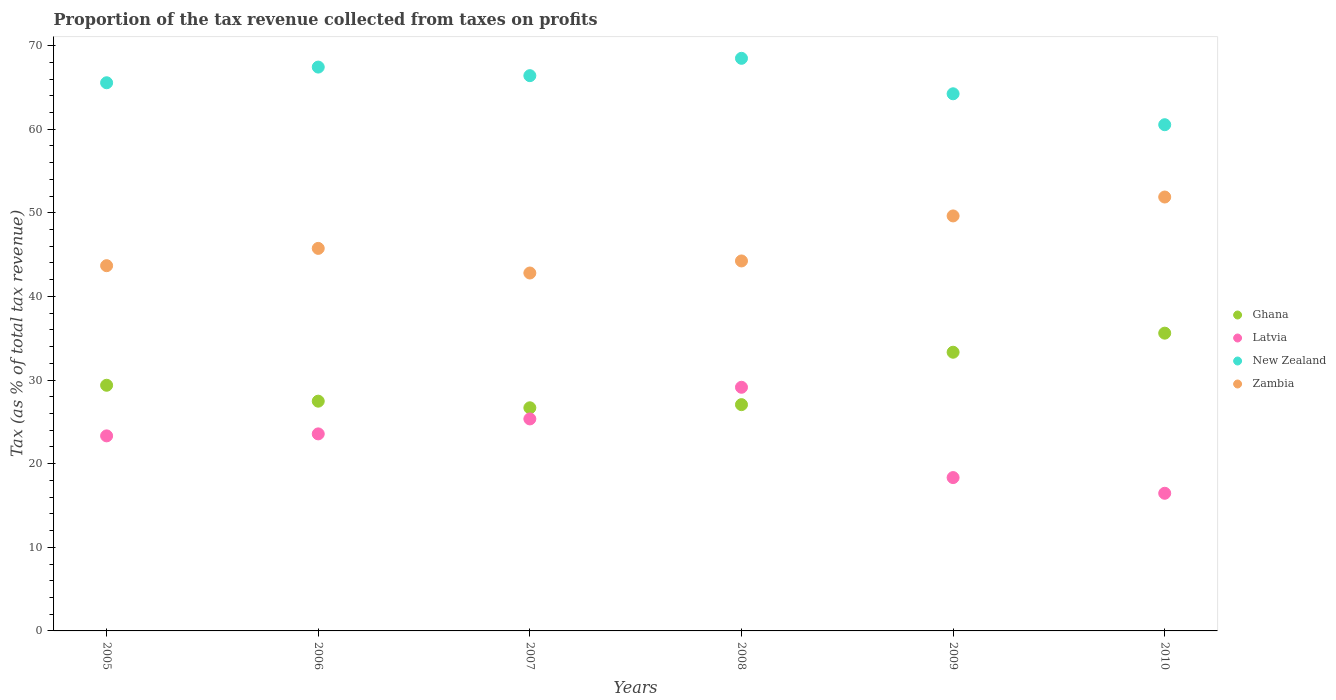What is the proportion of the tax revenue collected in New Zealand in 2007?
Your response must be concise. 66.4. Across all years, what is the maximum proportion of the tax revenue collected in New Zealand?
Your answer should be compact. 68.47. Across all years, what is the minimum proportion of the tax revenue collected in Latvia?
Keep it short and to the point. 16.46. What is the total proportion of the tax revenue collected in Latvia in the graph?
Provide a succinct answer. 136.17. What is the difference between the proportion of the tax revenue collected in Ghana in 2006 and that in 2010?
Make the answer very short. -8.13. What is the difference between the proportion of the tax revenue collected in New Zealand in 2008 and the proportion of the tax revenue collected in Zambia in 2010?
Provide a succinct answer. 16.59. What is the average proportion of the tax revenue collected in New Zealand per year?
Your answer should be compact. 65.44. In the year 2007, what is the difference between the proportion of the tax revenue collected in Ghana and proportion of the tax revenue collected in New Zealand?
Your answer should be very brief. -39.72. In how many years, is the proportion of the tax revenue collected in Zambia greater than 24 %?
Your response must be concise. 6. What is the ratio of the proportion of the tax revenue collected in Latvia in 2005 to that in 2010?
Ensure brevity in your answer.  1.42. Is the proportion of the tax revenue collected in Ghana in 2009 less than that in 2010?
Offer a terse response. Yes. What is the difference between the highest and the second highest proportion of the tax revenue collected in Latvia?
Your answer should be very brief. 3.78. What is the difference between the highest and the lowest proportion of the tax revenue collected in Zambia?
Ensure brevity in your answer.  9.09. In how many years, is the proportion of the tax revenue collected in Zambia greater than the average proportion of the tax revenue collected in Zambia taken over all years?
Give a very brief answer. 2. Is it the case that in every year, the sum of the proportion of the tax revenue collected in Zambia and proportion of the tax revenue collected in New Zealand  is greater than the sum of proportion of the tax revenue collected in Latvia and proportion of the tax revenue collected in Ghana?
Provide a succinct answer. No. Does the proportion of the tax revenue collected in Ghana monotonically increase over the years?
Keep it short and to the point. No. Is the proportion of the tax revenue collected in Zambia strictly greater than the proportion of the tax revenue collected in New Zealand over the years?
Ensure brevity in your answer.  No. Is the proportion of the tax revenue collected in Ghana strictly less than the proportion of the tax revenue collected in New Zealand over the years?
Your answer should be very brief. Yes. How many years are there in the graph?
Keep it short and to the point. 6. Does the graph contain any zero values?
Ensure brevity in your answer.  No. Does the graph contain grids?
Give a very brief answer. No. How many legend labels are there?
Make the answer very short. 4. How are the legend labels stacked?
Your response must be concise. Vertical. What is the title of the graph?
Ensure brevity in your answer.  Proportion of the tax revenue collected from taxes on profits. What is the label or title of the X-axis?
Offer a terse response. Years. What is the label or title of the Y-axis?
Provide a short and direct response. Tax (as % of total tax revenue). What is the Tax (as % of total tax revenue) in Ghana in 2005?
Your response must be concise. 29.38. What is the Tax (as % of total tax revenue) of Latvia in 2005?
Your answer should be compact. 23.32. What is the Tax (as % of total tax revenue) of New Zealand in 2005?
Offer a very short reply. 65.55. What is the Tax (as % of total tax revenue) of Zambia in 2005?
Your answer should be very brief. 43.68. What is the Tax (as % of total tax revenue) of Ghana in 2006?
Your answer should be compact. 27.47. What is the Tax (as % of total tax revenue) of Latvia in 2006?
Offer a terse response. 23.56. What is the Tax (as % of total tax revenue) of New Zealand in 2006?
Keep it short and to the point. 67.43. What is the Tax (as % of total tax revenue) of Zambia in 2006?
Provide a succinct answer. 45.74. What is the Tax (as % of total tax revenue) of Ghana in 2007?
Provide a short and direct response. 26.68. What is the Tax (as % of total tax revenue) of Latvia in 2007?
Give a very brief answer. 25.35. What is the Tax (as % of total tax revenue) in New Zealand in 2007?
Your answer should be very brief. 66.4. What is the Tax (as % of total tax revenue) in Zambia in 2007?
Your answer should be compact. 42.8. What is the Tax (as % of total tax revenue) in Ghana in 2008?
Ensure brevity in your answer.  27.06. What is the Tax (as % of total tax revenue) of Latvia in 2008?
Keep it short and to the point. 29.14. What is the Tax (as % of total tax revenue) of New Zealand in 2008?
Offer a very short reply. 68.47. What is the Tax (as % of total tax revenue) in Zambia in 2008?
Your answer should be compact. 44.24. What is the Tax (as % of total tax revenue) in Ghana in 2009?
Give a very brief answer. 33.33. What is the Tax (as % of total tax revenue) of Latvia in 2009?
Your answer should be compact. 18.34. What is the Tax (as % of total tax revenue) of New Zealand in 2009?
Keep it short and to the point. 64.23. What is the Tax (as % of total tax revenue) of Zambia in 2009?
Provide a short and direct response. 49.63. What is the Tax (as % of total tax revenue) in Ghana in 2010?
Give a very brief answer. 35.61. What is the Tax (as % of total tax revenue) in Latvia in 2010?
Offer a terse response. 16.46. What is the Tax (as % of total tax revenue) of New Zealand in 2010?
Provide a short and direct response. 60.53. What is the Tax (as % of total tax revenue) in Zambia in 2010?
Your answer should be compact. 51.89. Across all years, what is the maximum Tax (as % of total tax revenue) of Ghana?
Make the answer very short. 35.61. Across all years, what is the maximum Tax (as % of total tax revenue) of Latvia?
Your answer should be very brief. 29.14. Across all years, what is the maximum Tax (as % of total tax revenue) of New Zealand?
Provide a short and direct response. 68.47. Across all years, what is the maximum Tax (as % of total tax revenue) of Zambia?
Ensure brevity in your answer.  51.89. Across all years, what is the minimum Tax (as % of total tax revenue) in Ghana?
Your answer should be compact. 26.68. Across all years, what is the minimum Tax (as % of total tax revenue) of Latvia?
Offer a very short reply. 16.46. Across all years, what is the minimum Tax (as % of total tax revenue) in New Zealand?
Offer a terse response. 60.53. Across all years, what is the minimum Tax (as % of total tax revenue) of Zambia?
Your response must be concise. 42.8. What is the total Tax (as % of total tax revenue) in Ghana in the graph?
Your response must be concise. 179.53. What is the total Tax (as % of total tax revenue) in Latvia in the graph?
Offer a very short reply. 136.17. What is the total Tax (as % of total tax revenue) in New Zealand in the graph?
Your answer should be very brief. 392.62. What is the total Tax (as % of total tax revenue) in Zambia in the graph?
Your answer should be compact. 277.98. What is the difference between the Tax (as % of total tax revenue) of Ghana in 2005 and that in 2006?
Ensure brevity in your answer.  1.9. What is the difference between the Tax (as % of total tax revenue) of Latvia in 2005 and that in 2006?
Your response must be concise. -0.24. What is the difference between the Tax (as % of total tax revenue) in New Zealand in 2005 and that in 2006?
Keep it short and to the point. -1.88. What is the difference between the Tax (as % of total tax revenue) of Zambia in 2005 and that in 2006?
Give a very brief answer. -2.07. What is the difference between the Tax (as % of total tax revenue) in Ghana in 2005 and that in 2007?
Your answer should be compact. 2.69. What is the difference between the Tax (as % of total tax revenue) in Latvia in 2005 and that in 2007?
Your answer should be compact. -2.03. What is the difference between the Tax (as % of total tax revenue) in New Zealand in 2005 and that in 2007?
Ensure brevity in your answer.  -0.85. What is the difference between the Tax (as % of total tax revenue) of Zambia in 2005 and that in 2007?
Offer a very short reply. 0.88. What is the difference between the Tax (as % of total tax revenue) of Ghana in 2005 and that in 2008?
Ensure brevity in your answer.  2.32. What is the difference between the Tax (as % of total tax revenue) of Latvia in 2005 and that in 2008?
Keep it short and to the point. -5.81. What is the difference between the Tax (as % of total tax revenue) of New Zealand in 2005 and that in 2008?
Keep it short and to the point. -2.92. What is the difference between the Tax (as % of total tax revenue) of Zambia in 2005 and that in 2008?
Provide a short and direct response. -0.57. What is the difference between the Tax (as % of total tax revenue) in Ghana in 2005 and that in 2009?
Your response must be concise. -3.95. What is the difference between the Tax (as % of total tax revenue) in Latvia in 2005 and that in 2009?
Provide a succinct answer. 4.99. What is the difference between the Tax (as % of total tax revenue) in New Zealand in 2005 and that in 2009?
Give a very brief answer. 1.32. What is the difference between the Tax (as % of total tax revenue) in Zambia in 2005 and that in 2009?
Ensure brevity in your answer.  -5.95. What is the difference between the Tax (as % of total tax revenue) in Ghana in 2005 and that in 2010?
Make the answer very short. -6.23. What is the difference between the Tax (as % of total tax revenue) of Latvia in 2005 and that in 2010?
Provide a succinct answer. 6.86. What is the difference between the Tax (as % of total tax revenue) of New Zealand in 2005 and that in 2010?
Your answer should be very brief. 5.02. What is the difference between the Tax (as % of total tax revenue) in Zambia in 2005 and that in 2010?
Provide a short and direct response. -8.21. What is the difference between the Tax (as % of total tax revenue) in Ghana in 2006 and that in 2007?
Offer a terse response. 0.79. What is the difference between the Tax (as % of total tax revenue) in Latvia in 2006 and that in 2007?
Your answer should be very brief. -1.79. What is the difference between the Tax (as % of total tax revenue) in New Zealand in 2006 and that in 2007?
Offer a very short reply. 1.03. What is the difference between the Tax (as % of total tax revenue) in Zambia in 2006 and that in 2007?
Your answer should be very brief. 2.94. What is the difference between the Tax (as % of total tax revenue) of Ghana in 2006 and that in 2008?
Offer a very short reply. 0.42. What is the difference between the Tax (as % of total tax revenue) of Latvia in 2006 and that in 2008?
Offer a terse response. -5.57. What is the difference between the Tax (as % of total tax revenue) in New Zealand in 2006 and that in 2008?
Keep it short and to the point. -1.05. What is the difference between the Tax (as % of total tax revenue) of Zambia in 2006 and that in 2008?
Your response must be concise. 1.5. What is the difference between the Tax (as % of total tax revenue) of Ghana in 2006 and that in 2009?
Keep it short and to the point. -5.85. What is the difference between the Tax (as % of total tax revenue) of Latvia in 2006 and that in 2009?
Offer a very short reply. 5.22. What is the difference between the Tax (as % of total tax revenue) of New Zealand in 2006 and that in 2009?
Offer a very short reply. 3.19. What is the difference between the Tax (as % of total tax revenue) of Zambia in 2006 and that in 2009?
Your response must be concise. -3.88. What is the difference between the Tax (as % of total tax revenue) of Ghana in 2006 and that in 2010?
Provide a short and direct response. -8.13. What is the difference between the Tax (as % of total tax revenue) in Latvia in 2006 and that in 2010?
Ensure brevity in your answer.  7.1. What is the difference between the Tax (as % of total tax revenue) in New Zealand in 2006 and that in 2010?
Provide a succinct answer. 6.89. What is the difference between the Tax (as % of total tax revenue) in Zambia in 2006 and that in 2010?
Your answer should be very brief. -6.14. What is the difference between the Tax (as % of total tax revenue) in Ghana in 2007 and that in 2008?
Your answer should be very brief. -0.38. What is the difference between the Tax (as % of total tax revenue) of Latvia in 2007 and that in 2008?
Your answer should be compact. -3.78. What is the difference between the Tax (as % of total tax revenue) of New Zealand in 2007 and that in 2008?
Offer a terse response. -2.07. What is the difference between the Tax (as % of total tax revenue) of Zambia in 2007 and that in 2008?
Provide a short and direct response. -1.44. What is the difference between the Tax (as % of total tax revenue) in Ghana in 2007 and that in 2009?
Provide a succinct answer. -6.64. What is the difference between the Tax (as % of total tax revenue) of Latvia in 2007 and that in 2009?
Offer a terse response. 7.01. What is the difference between the Tax (as % of total tax revenue) in New Zealand in 2007 and that in 2009?
Offer a very short reply. 2.17. What is the difference between the Tax (as % of total tax revenue) in Zambia in 2007 and that in 2009?
Give a very brief answer. -6.83. What is the difference between the Tax (as % of total tax revenue) in Ghana in 2007 and that in 2010?
Provide a succinct answer. -8.92. What is the difference between the Tax (as % of total tax revenue) of Latvia in 2007 and that in 2010?
Your response must be concise. 8.89. What is the difference between the Tax (as % of total tax revenue) in New Zealand in 2007 and that in 2010?
Your answer should be very brief. 5.87. What is the difference between the Tax (as % of total tax revenue) in Zambia in 2007 and that in 2010?
Your response must be concise. -9.09. What is the difference between the Tax (as % of total tax revenue) in Ghana in 2008 and that in 2009?
Provide a succinct answer. -6.27. What is the difference between the Tax (as % of total tax revenue) of Latvia in 2008 and that in 2009?
Your answer should be very brief. 10.8. What is the difference between the Tax (as % of total tax revenue) in New Zealand in 2008 and that in 2009?
Ensure brevity in your answer.  4.24. What is the difference between the Tax (as % of total tax revenue) of Zambia in 2008 and that in 2009?
Provide a short and direct response. -5.38. What is the difference between the Tax (as % of total tax revenue) in Ghana in 2008 and that in 2010?
Provide a succinct answer. -8.55. What is the difference between the Tax (as % of total tax revenue) in Latvia in 2008 and that in 2010?
Ensure brevity in your answer.  12.68. What is the difference between the Tax (as % of total tax revenue) of New Zealand in 2008 and that in 2010?
Keep it short and to the point. 7.94. What is the difference between the Tax (as % of total tax revenue) of Zambia in 2008 and that in 2010?
Give a very brief answer. -7.64. What is the difference between the Tax (as % of total tax revenue) of Ghana in 2009 and that in 2010?
Your answer should be compact. -2.28. What is the difference between the Tax (as % of total tax revenue) in Latvia in 2009 and that in 2010?
Provide a short and direct response. 1.88. What is the difference between the Tax (as % of total tax revenue) in New Zealand in 2009 and that in 2010?
Offer a very short reply. 3.7. What is the difference between the Tax (as % of total tax revenue) in Zambia in 2009 and that in 2010?
Make the answer very short. -2.26. What is the difference between the Tax (as % of total tax revenue) of Ghana in 2005 and the Tax (as % of total tax revenue) of Latvia in 2006?
Give a very brief answer. 5.81. What is the difference between the Tax (as % of total tax revenue) of Ghana in 2005 and the Tax (as % of total tax revenue) of New Zealand in 2006?
Provide a succinct answer. -38.05. What is the difference between the Tax (as % of total tax revenue) of Ghana in 2005 and the Tax (as % of total tax revenue) of Zambia in 2006?
Your answer should be very brief. -16.37. What is the difference between the Tax (as % of total tax revenue) in Latvia in 2005 and the Tax (as % of total tax revenue) in New Zealand in 2006?
Your answer should be very brief. -44.1. What is the difference between the Tax (as % of total tax revenue) of Latvia in 2005 and the Tax (as % of total tax revenue) of Zambia in 2006?
Provide a succinct answer. -22.42. What is the difference between the Tax (as % of total tax revenue) of New Zealand in 2005 and the Tax (as % of total tax revenue) of Zambia in 2006?
Your answer should be very brief. 19.81. What is the difference between the Tax (as % of total tax revenue) in Ghana in 2005 and the Tax (as % of total tax revenue) in Latvia in 2007?
Provide a short and direct response. 4.02. What is the difference between the Tax (as % of total tax revenue) in Ghana in 2005 and the Tax (as % of total tax revenue) in New Zealand in 2007?
Provide a short and direct response. -37.02. What is the difference between the Tax (as % of total tax revenue) in Ghana in 2005 and the Tax (as % of total tax revenue) in Zambia in 2007?
Give a very brief answer. -13.42. What is the difference between the Tax (as % of total tax revenue) of Latvia in 2005 and the Tax (as % of total tax revenue) of New Zealand in 2007?
Your answer should be compact. -43.07. What is the difference between the Tax (as % of total tax revenue) of Latvia in 2005 and the Tax (as % of total tax revenue) of Zambia in 2007?
Keep it short and to the point. -19.48. What is the difference between the Tax (as % of total tax revenue) of New Zealand in 2005 and the Tax (as % of total tax revenue) of Zambia in 2007?
Offer a terse response. 22.75. What is the difference between the Tax (as % of total tax revenue) in Ghana in 2005 and the Tax (as % of total tax revenue) in Latvia in 2008?
Provide a succinct answer. 0.24. What is the difference between the Tax (as % of total tax revenue) in Ghana in 2005 and the Tax (as % of total tax revenue) in New Zealand in 2008?
Make the answer very short. -39.1. What is the difference between the Tax (as % of total tax revenue) in Ghana in 2005 and the Tax (as % of total tax revenue) in Zambia in 2008?
Ensure brevity in your answer.  -14.87. What is the difference between the Tax (as % of total tax revenue) of Latvia in 2005 and the Tax (as % of total tax revenue) of New Zealand in 2008?
Your response must be concise. -45.15. What is the difference between the Tax (as % of total tax revenue) of Latvia in 2005 and the Tax (as % of total tax revenue) of Zambia in 2008?
Offer a very short reply. -20.92. What is the difference between the Tax (as % of total tax revenue) in New Zealand in 2005 and the Tax (as % of total tax revenue) in Zambia in 2008?
Give a very brief answer. 21.31. What is the difference between the Tax (as % of total tax revenue) of Ghana in 2005 and the Tax (as % of total tax revenue) of Latvia in 2009?
Your response must be concise. 11.04. What is the difference between the Tax (as % of total tax revenue) of Ghana in 2005 and the Tax (as % of total tax revenue) of New Zealand in 2009?
Offer a terse response. -34.86. What is the difference between the Tax (as % of total tax revenue) of Ghana in 2005 and the Tax (as % of total tax revenue) of Zambia in 2009?
Offer a terse response. -20.25. What is the difference between the Tax (as % of total tax revenue) of Latvia in 2005 and the Tax (as % of total tax revenue) of New Zealand in 2009?
Make the answer very short. -40.91. What is the difference between the Tax (as % of total tax revenue) of Latvia in 2005 and the Tax (as % of total tax revenue) of Zambia in 2009?
Keep it short and to the point. -26.3. What is the difference between the Tax (as % of total tax revenue) of New Zealand in 2005 and the Tax (as % of total tax revenue) of Zambia in 2009?
Your answer should be compact. 15.92. What is the difference between the Tax (as % of total tax revenue) in Ghana in 2005 and the Tax (as % of total tax revenue) in Latvia in 2010?
Provide a short and direct response. 12.92. What is the difference between the Tax (as % of total tax revenue) of Ghana in 2005 and the Tax (as % of total tax revenue) of New Zealand in 2010?
Keep it short and to the point. -31.16. What is the difference between the Tax (as % of total tax revenue) of Ghana in 2005 and the Tax (as % of total tax revenue) of Zambia in 2010?
Your answer should be very brief. -22.51. What is the difference between the Tax (as % of total tax revenue) in Latvia in 2005 and the Tax (as % of total tax revenue) in New Zealand in 2010?
Give a very brief answer. -37.21. What is the difference between the Tax (as % of total tax revenue) of Latvia in 2005 and the Tax (as % of total tax revenue) of Zambia in 2010?
Your response must be concise. -28.56. What is the difference between the Tax (as % of total tax revenue) of New Zealand in 2005 and the Tax (as % of total tax revenue) of Zambia in 2010?
Provide a succinct answer. 13.66. What is the difference between the Tax (as % of total tax revenue) in Ghana in 2006 and the Tax (as % of total tax revenue) in Latvia in 2007?
Make the answer very short. 2.12. What is the difference between the Tax (as % of total tax revenue) in Ghana in 2006 and the Tax (as % of total tax revenue) in New Zealand in 2007?
Give a very brief answer. -38.92. What is the difference between the Tax (as % of total tax revenue) in Ghana in 2006 and the Tax (as % of total tax revenue) in Zambia in 2007?
Provide a short and direct response. -15.33. What is the difference between the Tax (as % of total tax revenue) in Latvia in 2006 and the Tax (as % of total tax revenue) in New Zealand in 2007?
Your answer should be very brief. -42.84. What is the difference between the Tax (as % of total tax revenue) of Latvia in 2006 and the Tax (as % of total tax revenue) of Zambia in 2007?
Your answer should be very brief. -19.24. What is the difference between the Tax (as % of total tax revenue) of New Zealand in 2006 and the Tax (as % of total tax revenue) of Zambia in 2007?
Your response must be concise. 24.63. What is the difference between the Tax (as % of total tax revenue) of Ghana in 2006 and the Tax (as % of total tax revenue) of Latvia in 2008?
Your response must be concise. -1.66. What is the difference between the Tax (as % of total tax revenue) in Ghana in 2006 and the Tax (as % of total tax revenue) in New Zealand in 2008?
Provide a succinct answer. -41. What is the difference between the Tax (as % of total tax revenue) of Ghana in 2006 and the Tax (as % of total tax revenue) of Zambia in 2008?
Offer a very short reply. -16.77. What is the difference between the Tax (as % of total tax revenue) in Latvia in 2006 and the Tax (as % of total tax revenue) in New Zealand in 2008?
Provide a short and direct response. -44.91. What is the difference between the Tax (as % of total tax revenue) of Latvia in 2006 and the Tax (as % of total tax revenue) of Zambia in 2008?
Your response must be concise. -20.68. What is the difference between the Tax (as % of total tax revenue) of New Zealand in 2006 and the Tax (as % of total tax revenue) of Zambia in 2008?
Make the answer very short. 23.18. What is the difference between the Tax (as % of total tax revenue) of Ghana in 2006 and the Tax (as % of total tax revenue) of Latvia in 2009?
Offer a very short reply. 9.14. What is the difference between the Tax (as % of total tax revenue) in Ghana in 2006 and the Tax (as % of total tax revenue) in New Zealand in 2009?
Provide a short and direct response. -36.76. What is the difference between the Tax (as % of total tax revenue) of Ghana in 2006 and the Tax (as % of total tax revenue) of Zambia in 2009?
Make the answer very short. -22.15. What is the difference between the Tax (as % of total tax revenue) in Latvia in 2006 and the Tax (as % of total tax revenue) in New Zealand in 2009?
Provide a short and direct response. -40.67. What is the difference between the Tax (as % of total tax revenue) in Latvia in 2006 and the Tax (as % of total tax revenue) in Zambia in 2009?
Give a very brief answer. -26.07. What is the difference between the Tax (as % of total tax revenue) of New Zealand in 2006 and the Tax (as % of total tax revenue) of Zambia in 2009?
Keep it short and to the point. 17.8. What is the difference between the Tax (as % of total tax revenue) of Ghana in 2006 and the Tax (as % of total tax revenue) of Latvia in 2010?
Offer a very short reply. 11.01. What is the difference between the Tax (as % of total tax revenue) in Ghana in 2006 and the Tax (as % of total tax revenue) in New Zealand in 2010?
Ensure brevity in your answer.  -33.06. What is the difference between the Tax (as % of total tax revenue) in Ghana in 2006 and the Tax (as % of total tax revenue) in Zambia in 2010?
Keep it short and to the point. -24.41. What is the difference between the Tax (as % of total tax revenue) in Latvia in 2006 and the Tax (as % of total tax revenue) in New Zealand in 2010?
Offer a very short reply. -36.97. What is the difference between the Tax (as % of total tax revenue) of Latvia in 2006 and the Tax (as % of total tax revenue) of Zambia in 2010?
Your response must be concise. -28.33. What is the difference between the Tax (as % of total tax revenue) in New Zealand in 2006 and the Tax (as % of total tax revenue) in Zambia in 2010?
Ensure brevity in your answer.  15.54. What is the difference between the Tax (as % of total tax revenue) in Ghana in 2007 and the Tax (as % of total tax revenue) in Latvia in 2008?
Your answer should be very brief. -2.45. What is the difference between the Tax (as % of total tax revenue) in Ghana in 2007 and the Tax (as % of total tax revenue) in New Zealand in 2008?
Make the answer very short. -41.79. What is the difference between the Tax (as % of total tax revenue) in Ghana in 2007 and the Tax (as % of total tax revenue) in Zambia in 2008?
Your response must be concise. -17.56. What is the difference between the Tax (as % of total tax revenue) in Latvia in 2007 and the Tax (as % of total tax revenue) in New Zealand in 2008?
Your response must be concise. -43.12. What is the difference between the Tax (as % of total tax revenue) of Latvia in 2007 and the Tax (as % of total tax revenue) of Zambia in 2008?
Provide a short and direct response. -18.89. What is the difference between the Tax (as % of total tax revenue) of New Zealand in 2007 and the Tax (as % of total tax revenue) of Zambia in 2008?
Your response must be concise. 22.16. What is the difference between the Tax (as % of total tax revenue) in Ghana in 2007 and the Tax (as % of total tax revenue) in Latvia in 2009?
Offer a very short reply. 8.35. What is the difference between the Tax (as % of total tax revenue) in Ghana in 2007 and the Tax (as % of total tax revenue) in New Zealand in 2009?
Give a very brief answer. -37.55. What is the difference between the Tax (as % of total tax revenue) of Ghana in 2007 and the Tax (as % of total tax revenue) of Zambia in 2009?
Your answer should be very brief. -22.94. What is the difference between the Tax (as % of total tax revenue) of Latvia in 2007 and the Tax (as % of total tax revenue) of New Zealand in 2009?
Your answer should be compact. -38.88. What is the difference between the Tax (as % of total tax revenue) of Latvia in 2007 and the Tax (as % of total tax revenue) of Zambia in 2009?
Provide a short and direct response. -24.28. What is the difference between the Tax (as % of total tax revenue) in New Zealand in 2007 and the Tax (as % of total tax revenue) in Zambia in 2009?
Offer a very short reply. 16.77. What is the difference between the Tax (as % of total tax revenue) in Ghana in 2007 and the Tax (as % of total tax revenue) in Latvia in 2010?
Ensure brevity in your answer.  10.22. What is the difference between the Tax (as % of total tax revenue) in Ghana in 2007 and the Tax (as % of total tax revenue) in New Zealand in 2010?
Provide a short and direct response. -33.85. What is the difference between the Tax (as % of total tax revenue) of Ghana in 2007 and the Tax (as % of total tax revenue) of Zambia in 2010?
Provide a short and direct response. -25.2. What is the difference between the Tax (as % of total tax revenue) of Latvia in 2007 and the Tax (as % of total tax revenue) of New Zealand in 2010?
Make the answer very short. -35.18. What is the difference between the Tax (as % of total tax revenue) of Latvia in 2007 and the Tax (as % of total tax revenue) of Zambia in 2010?
Offer a very short reply. -26.54. What is the difference between the Tax (as % of total tax revenue) of New Zealand in 2007 and the Tax (as % of total tax revenue) of Zambia in 2010?
Make the answer very short. 14.51. What is the difference between the Tax (as % of total tax revenue) of Ghana in 2008 and the Tax (as % of total tax revenue) of Latvia in 2009?
Give a very brief answer. 8.72. What is the difference between the Tax (as % of total tax revenue) of Ghana in 2008 and the Tax (as % of total tax revenue) of New Zealand in 2009?
Ensure brevity in your answer.  -37.17. What is the difference between the Tax (as % of total tax revenue) of Ghana in 2008 and the Tax (as % of total tax revenue) of Zambia in 2009?
Offer a very short reply. -22.57. What is the difference between the Tax (as % of total tax revenue) in Latvia in 2008 and the Tax (as % of total tax revenue) in New Zealand in 2009?
Your answer should be very brief. -35.1. What is the difference between the Tax (as % of total tax revenue) in Latvia in 2008 and the Tax (as % of total tax revenue) in Zambia in 2009?
Give a very brief answer. -20.49. What is the difference between the Tax (as % of total tax revenue) in New Zealand in 2008 and the Tax (as % of total tax revenue) in Zambia in 2009?
Ensure brevity in your answer.  18.85. What is the difference between the Tax (as % of total tax revenue) of Ghana in 2008 and the Tax (as % of total tax revenue) of Latvia in 2010?
Offer a terse response. 10.6. What is the difference between the Tax (as % of total tax revenue) in Ghana in 2008 and the Tax (as % of total tax revenue) in New Zealand in 2010?
Provide a succinct answer. -33.47. What is the difference between the Tax (as % of total tax revenue) in Ghana in 2008 and the Tax (as % of total tax revenue) in Zambia in 2010?
Your answer should be very brief. -24.83. What is the difference between the Tax (as % of total tax revenue) in Latvia in 2008 and the Tax (as % of total tax revenue) in New Zealand in 2010?
Provide a succinct answer. -31.4. What is the difference between the Tax (as % of total tax revenue) of Latvia in 2008 and the Tax (as % of total tax revenue) of Zambia in 2010?
Your answer should be very brief. -22.75. What is the difference between the Tax (as % of total tax revenue) in New Zealand in 2008 and the Tax (as % of total tax revenue) in Zambia in 2010?
Provide a short and direct response. 16.59. What is the difference between the Tax (as % of total tax revenue) of Ghana in 2009 and the Tax (as % of total tax revenue) of Latvia in 2010?
Give a very brief answer. 16.87. What is the difference between the Tax (as % of total tax revenue) in Ghana in 2009 and the Tax (as % of total tax revenue) in New Zealand in 2010?
Offer a terse response. -27.21. What is the difference between the Tax (as % of total tax revenue) of Ghana in 2009 and the Tax (as % of total tax revenue) of Zambia in 2010?
Provide a succinct answer. -18.56. What is the difference between the Tax (as % of total tax revenue) in Latvia in 2009 and the Tax (as % of total tax revenue) in New Zealand in 2010?
Make the answer very short. -42.2. What is the difference between the Tax (as % of total tax revenue) of Latvia in 2009 and the Tax (as % of total tax revenue) of Zambia in 2010?
Offer a terse response. -33.55. What is the difference between the Tax (as % of total tax revenue) in New Zealand in 2009 and the Tax (as % of total tax revenue) in Zambia in 2010?
Your answer should be very brief. 12.34. What is the average Tax (as % of total tax revenue) in Ghana per year?
Offer a very short reply. 29.92. What is the average Tax (as % of total tax revenue) in Latvia per year?
Your response must be concise. 22.7. What is the average Tax (as % of total tax revenue) in New Zealand per year?
Provide a succinct answer. 65.44. What is the average Tax (as % of total tax revenue) in Zambia per year?
Make the answer very short. 46.33. In the year 2005, what is the difference between the Tax (as % of total tax revenue) of Ghana and Tax (as % of total tax revenue) of Latvia?
Provide a short and direct response. 6.05. In the year 2005, what is the difference between the Tax (as % of total tax revenue) in Ghana and Tax (as % of total tax revenue) in New Zealand?
Provide a short and direct response. -36.17. In the year 2005, what is the difference between the Tax (as % of total tax revenue) in Ghana and Tax (as % of total tax revenue) in Zambia?
Your answer should be compact. -14.3. In the year 2005, what is the difference between the Tax (as % of total tax revenue) in Latvia and Tax (as % of total tax revenue) in New Zealand?
Offer a very short reply. -42.23. In the year 2005, what is the difference between the Tax (as % of total tax revenue) in Latvia and Tax (as % of total tax revenue) in Zambia?
Give a very brief answer. -20.35. In the year 2005, what is the difference between the Tax (as % of total tax revenue) of New Zealand and Tax (as % of total tax revenue) of Zambia?
Your answer should be compact. 21.87. In the year 2006, what is the difference between the Tax (as % of total tax revenue) in Ghana and Tax (as % of total tax revenue) in Latvia?
Offer a very short reply. 3.91. In the year 2006, what is the difference between the Tax (as % of total tax revenue) of Ghana and Tax (as % of total tax revenue) of New Zealand?
Make the answer very short. -39.95. In the year 2006, what is the difference between the Tax (as % of total tax revenue) of Ghana and Tax (as % of total tax revenue) of Zambia?
Give a very brief answer. -18.27. In the year 2006, what is the difference between the Tax (as % of total tax revenue) in Latvia and Tax (as % of total tax revenue) in New Zealand?
Give a very brief answer. -43.86. In the year 2006, what is the difference between the Tax (as % of total tax revenue) in Latvia and Tax (as % of total tax revenue) in Zambia?
Provide a succinct answer. -22.18. In the year 2006, what is the difference between the Tax (as % of total tax revenue) of New Zealand and Tax (as % of total tax revenue) of Zambia?
Your answer should be very brief. 21.68. In the year 2007, what is the difference between the Tax (as % of total tax revenue) in Ghana and Tax (as % of total tax revenue) in Latvia?
Your response must be concise. 1.33. In the year 2007, what is the difference between the Tax (as % of total tax revenue) in Ghana and Tax (as % of total tax revenue) in New Zealand?
Provide a short and direct response. -39.72. In the year 2007, what is the difference between the Tax (as % of total tax revenue) of Ghana and Tax (as % of total tax revenue) of Zambia?
Provide a short and direct response. -16.12. In the year 2007, what is the difference between the Tax (as % of total tax revenue) of Latvia and Tax (as % of total tax revenue) of New Zealand?
Your answer should be compact. -41.05. In the year 2007, what is the difference between the Tax (as % of total tax revenue) in Latvia and Tax (as % of total tax revenue) in Zambia?
Your response must be concise. -17.45. In the year 2007, what is the difference between the Tax (as % of total tax revenue) of New Zealand and Tax (as % of total tax revenue) of Zambia?
Provide a succinct answer. 23.6. In the year 2008, what is the difference between the Tax (as % of total tax revenue) in Ghana and Tax (as % of total tax revenue) in Latvia?
Keep it short and to the point. -2.08. In the year 2008, what is the difference between the Tax (as % of total tax revenue) in Ghana and Tax (as % of total tax revenue) in New Zealand?
Your answer should be very brief. -41.41. In the year 2008, what is the difference between the Tax (as % of total tax revenue) of Ghana and Tax (as % of total tax revenue) of Zambia?
Offer a terse response. -17.18. In the year 2008, what is the difference between the Tax (as % of total tax revenue) of Latvia and Tax (as % of total tax revenue) of New Zealand?
Your answer should be compact. -39.34. In the year 2008, what is the difference between the Tax (as % of total tax revenue) in Latvia and Tax (as % of total tax revenue) in Zambia?
Offer a terse response. -15.11. In the year 2008, what is the difference between the Tax (as % of total tax revenue) in New Zealand and Tax (as % of total tax revenue) in Zambia?
Your answer should be compact. 24.23. In the year 2009, what is the difference between the Tax (as % of total tax revenue) in Ghana and Tax (as % of total tax revenue) in Latvia?
Offer a very short reply. 14.99. In the year 2009, what is the difference between the Tax (as % of total tax revenue) of Ghana and Tax (as % of total tax revenue) of New Zealand?
Give a very brief answer. -30.91. In the year 2009, what is the difference between the Tax (as % of total tax revenue) in Ghana and Tax (as % of total tax revenue) in Zambia?
Keep it short and to the point. -16.3. In the year 2009, what is the difference between the Tax (as % of total tax revenue) of Latvia and Tax (as % of total tax revenue) of New Zealand?
Offer a very short reply. -45.9. In the year 2009, what is the difference between the Tax (as % of total tax revenue) in Latvia and Tax (as % of total tax revenue) in Zambia?
Give a very brief answer. -31.29. In the year 2009, what is the difference between the Tax (as % of total tax revenue) in New Zealand and Tax (as % of total tax revenue) in Zambia?
Provide a short and direct response. 14.61. In the year 2010, what is the difference between the Tax (as % of total tax revenue) of Ghana and Tax (as % of total tax revenue) of Latvia?
Give a very brief answer. 19.15. In the year 2010, what is the difference between the Tax (as % of total tax revenue) of Ghana and Tax (as % of total tax revenue) of New Zealand?
Give a very brief answer. -24.93. In the year 2010, what is the difference between the Tax (as % of total tax revenue) in Ghana and Tax (as % of total tax revenue) in Zambia?
Your answer should be compact. -16.28. In the year 2010, what is the difference between the Tax (as % of total tax revenue) in Latvia and Tax (as % of total tax revenue) in New Zealand?
Make the answer very short. -44.07. In the year 2010, what is the difference between the Tax (as % of total tax revenue) in Latvia and Tax (as % of total tax revenue) in Zambia?
Give a very brief answer. -35.43. In the year 2010, what is the difference between the Tax (as % of total tax revenue) of New Zealand and Tax (as % of total tax revenue) of Zambia?
Keep it short and to the point. 8.65. What is the ratio of the Tax (as % of total tax revenue) of Ghana in 2005 to that in 2006?
Your answer should be very brief. 1.07. What is the ratio of the Tax (as % of total tax revenue) in New Zealand in 2005 to that in 2006?
Give a very brief answer. 0.97. What is the ratio of the Tax (as % of total tax revenue) in Zambia in 2005 to that in 2006?
Your answer should be compact. 0.95. What is the ratio of the Tax (as % of total tax revenue) of Ghana in 2005 to that in 2007?
Offer a terse response. 1.1. What is the ratio of the Tax (as % of total tax revenue) in Latvia in 2005 to that in 2007?
Provide a short and direct response. 0.92. What is the ratio of the Tax (as % of total tax revenue) in New Zealand in 2005 to that in 2007?
Provide a succinct answer. 0.99. What is the ratio of the Tax (as % of total tax revenue) of Zambia in 2005 to that in 2007?
Make the answer very short. 1.02. What is the ratio of the Tax (as % of total tax revenue) in Ghana in 2005 to that in 2008?
Offer a terse response. 1.09. What is the ratio of the Tax (as % of total tax revenue) in Latvia in 2005 to that in 2008?
Ensure brevity in your answer.  0.8. What is the ratio of the Tax (as % of total tax revenue) in New Zealand in 2005 to that in 2008?
Offer a very short reply. 0.96. What is the ratio of the Tax (as % of total tax revenue) in Zambia in 2005 to that in 2008?
Your answer should be very brief. 0.99. What is the ratio of the Tax (as % of total tax revenue) of Ghana in 2005 to that in 2009?
Offer a terse response. 0.88. What is the ratio of the Tax (as % of total tax revenue) in Latvia in 2005 to that in 2009?
Your answer should be compact. 1.27. What is the ratio of the Tax (as % of total tax revenue) in New Zealand in 2005 to that in 2009?
Offer a very short reply. 1.02. What is the ratio of the Tax (as % of total tax revenue) in Zambia in 2005 to that in 2009?
Provide a succinct answer. 0.88. What is the ratio of the Tax (as % of total tax revenue) in Ghana in 2005 to that in 2010?
Provide a succinct answer. 0.82. What is the ratio of the Tax (as % of total tax revenue) in Latvia in 2005 to that in 2010?
Offer a terse response. 1.42. What is the ratio of the Tax (as % of total tax revenue) in New Zealand in 2005 to that in 2010?
Your answer should be compact. 1.08. What is the ratio of the Tax (as % of total tax revenue) of Zambia in 2005 to that in 2010?
Offer a very short reply. 0.84. What is the ratio of the Tax (as % of total tax revenue) of Ghana in 2006 to that in 2007?
Make the answer very short. 1.03. What is the ratio of the Tax (as % of total tax revenue) in Latvia in 2006 to that in 2007?
Your response must be concise. 0.93. What is the ratio of the Tax (as % of total tax revenue) of New Zealand in 2006 to that in 2007?
Give a very brief answer. 1.02. What is the ratio of the Tax (as % of total tax revenue) in Zambia in 2006 to that in 2007?
Your answer should be compact. 1.07. What is the ratio of the Tax (as % of total tax revenue) in Ghana in 2006 to that in 2008?
Offer a very short reply. 1.02. What is the ratio of the Tax (as % of total tax revenue) in Latvia in 2006 to that in 2008?
Provide a succinct answer. 0.81. What is the ratio of the Tax (as % of total tax revenue) of New Zealand in 2006 to that in 2008?
Your response must be concise. 0.98. What is the ratio of the Tax (as % of total tax revenue) of Zambia in 2006 to that in 2008?
Make the answer very short. 1.03. What is the ratio of the Tax (as % of total tax revenue) of Ghana in 2006 to that in 2009?
Your response must be concise. 0.82. What is the ratio of the Tax (as % of total tax revenue) of Latvia in 2006 to that in 2009?
Provide a succinct answer. 1.28. What is the ratio of the Tax (as % of total tax revenue) of New Zealand in 2006 to that in 2009?
Your answer should be very brief. 1.05. What is the ratio of the Tax (as % of total tax revenue) of Zambia in 2006 to that in 2009?
Give a very brief answer. 0.92. What is the ratio of the Tax (as % of total tax revenue) of Ghana in 2006 to that in 2010?
Make the answer very short. 0.77. What is the ratio of the Tax (as % of total tax revenue) of Latvia in 2006 to that in 2010?
Keep it short and to the point. 1.43. What is the ratio of the Tax (as % of total tax revenue) in New Zealand in 2006 to that in 2010?
Offer a terse response. 1.11. What is the ratio of the Tax (as % of total tax revenue) in Zambia in 2006 to that in 2010?
Your answer should be compact. 0.88. What is the ratio of the Tax (as % of total tax revenue) in Ghana in 2007 to that in 2008?
Provide a succinct answer. 0.99. What is the ratio of the Tax (as % of total tax revenue) of Latvia in 2007 to that in 2008?
Ensure brevity in your answer.  0.87. What is the ratio of the Tax (as % of total tax revenue) of New Zealand in 2007 to that in 2008?
Offer a very short reply. 0.97. What is the ratio of the Tax (as % of total tax revenue) of Zambia in 2007 to that in 2008?
Your response must be concise. 0.97. What is the ratio of the Tax (as % of total tax revenue) of Ghana in 2007 to that in 2009?
Provide a short and direct response. 0.8. What is the ratio of the Tax (as % of total tax revenue) of Latvia in 2007 to that in 2009?
Your response must be concise. 1.38. What is the ratio of the Tax (as % of total tax revenue) of New Zealand in 2007 to that in 2009?
Provide a succinct answer. 1.03. What is the ratio of the Tax (as % of total tax revenue) of Zambia in 2007 to that in 2009?
Provide a succinct answer. 0.86. What is the ratio of the Tax (as % of total tax revenue) in Ghana in 2007 to that in 2010?
Your answer should be compact. 0.75. What is the ratio of the Tax (as % of total tax revenue) in Latvia in 2007 to that in 2010?
Your answer should be very brief. 1.54. What is the ratio of the Tax (as % of total tax revenue) in New Zealand in 2007 to that in 2010?
Offer a terse response. 1.1. What is the ratio of the Tax (as % of total tax revenue) in Zambia in 2007 to that in 2010?
Your answer should be very brief. 0.82. What is the ratio of the Tax (as % of total tax revenue) of Ghana in 2008 to that in 2009?
Your answer should be compact. 0.81. What is the ratio of the Tax (as % of total tax revenue) in Latvia in 2008 to that in 2009?
Provide a short and direct response. 1.59. What is the ratio of the Tax (as % of total tax revenue) of New Zealand in 2008 to that in 2009?
Provide a short and direct response. 1.07. What is the ratio of the Tax (as % of total tax revenue) in Zambia in 2008 to that in 2009?
Ensure brevity in your answer.  0.89. What is the ratio of the Tax (as % of total tax revenue) in Ghana in 2008 to that in 2010?
Give a very brief answer. 0.76. What is the ratio of the Tax (as % of total tax revenue) in Latvia in 2008 to that in 2010?
Ensure brevity in your answer.  1.77. What is the ratio of the Tax (as % of total tax revenue) of New Zealand in 2008 to that in 2010?
Give a very brief answer. 1.13. What is the ratio of the Tax (as % of total tax revenue) of Zambia in 2008 to that in 2010?
Offer a terse response. 0.85. What is the ratio of the Tax (as % of total tax revenue) of Ghana in 2009 to that in 2010?
Your answer should be very brief. 0.94. What is the ratio of the Tax (as % of total tax revenue) of Latvia in 2009 to that in 2010?
Ensure brevity in your answer.  1.11. What is the ratio of the Tax (as % of total tax revenue) of New Zealand in 2009 to that in 2010?
Your answer should be very brief. 1.06. What is the ratio of the Tax (as % of total tax revenue) of Zambia in 2009 to that in 2010?
Your answer should be compact. 0.96. What is the difference between the highest and the second highest Tax (as % of total tax revenue) in Ghana?
Provide a succinct answer. 2.28. What is the difference between the highest and the second highest Tax (as % of total tax revenue) of Latvia?
Offer a very short reply. 3.78. What is the difference between the highest and the second highest Tax (as % of total tax revenue) in New Zealand?
Your answer should be compact. 1.05. What is the difference between the highest and the second highest Tax (as % of total tax revenue) of Zambia?
Make the answer very short. 2.26. What is the difference between the highest and the lowest Tax (as % of total tax revenue) of Ghana?
Provide a succinct answer. 8.92. What is the difference between the highest and the lowest Tax (as % of total tax revenue) in Latvia?
Your answer should be very brief. 12.68. What is the difference between the highest and the lowest Tax (as % of total tax revenue) in New Zealand?
Offer a very short reply. 7.94. What is the difference between the highest and the lowest Tax (as % of total tax revenue) in Zambia?
Provide a succinct answer. 9.09. 